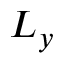Convert formula to latex. <formula><loc_0><loc_0><loc_500><loc_500>L _ { y }</formula> 